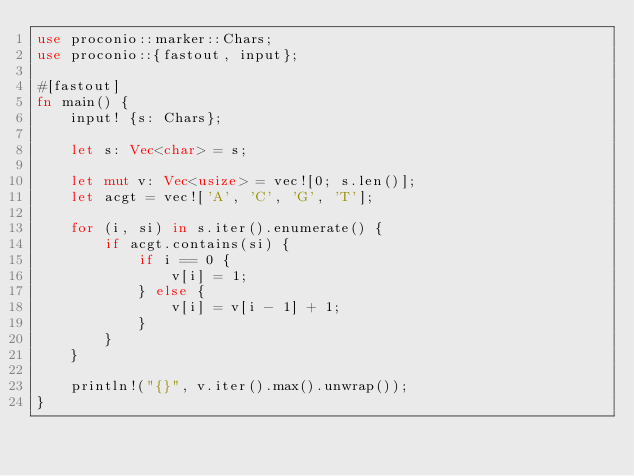Convert code to text. <code><loc_0><loc_0><loc_500><loc_500><_Rust_>use proconio::marker::Chars;
use proconio::{fastout, input};

#[fastout]
fn main() {
    input! {s: Chars};

    let s: Vec<char> = s;

    let mut v: Vec<usize> = vec![0; s.len()];
    let acgt = vec!['A', 'C', 'G', 'T'];

    for (i, si) in s.iter().enumerate() {
        if acgt.contains(si) {
            if i == 0 {
                v[i] = 1;
            } else {
                v[i] = v[i - 1] + 1;
            }
        }
    }

    println!("{}", v.iter().max().unwrap());
}
</code> 